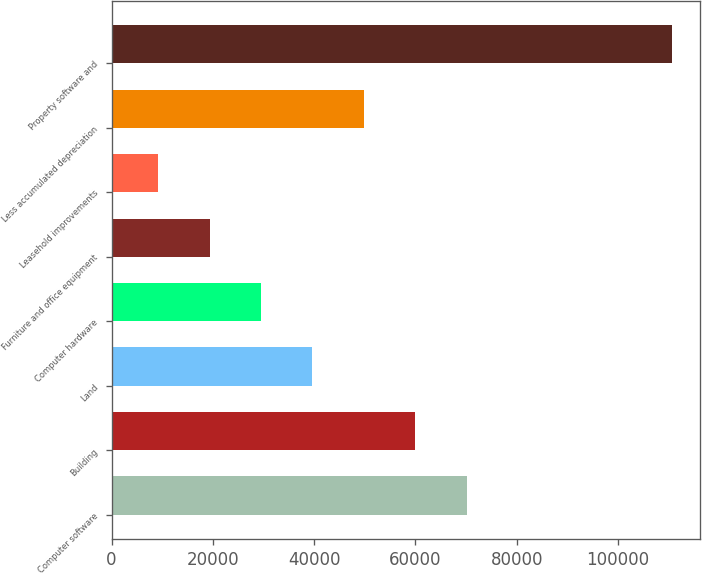<chart> <loc_0><loc_0><loc_500><loc_500><bar_chart><fcel>Computer software<fcel>Building<fcel>Land<fcel>Computer hardware<fcel>Furniture and office equipment<fcel>Leasehold improvements<fcel>Less accumulated depreciation<fcel>Property software and<nl><fcel>70103.2<fcel>59957<fcel>39664.6<fcel>29518.4<fcel>19372.2<fcel>9226<fcel>49810.8<fcel>110688<nl></chart> 